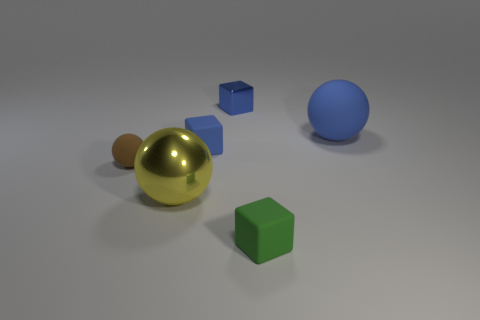Are any yellow metallic spheres visible?
Your response must be concise. Yes. There is a brown thing that is made of the same material as the green cube; what is its shape?
Provide a short and direct response. Sphere. There is a big ball on the right side of the green rubber block; what is it made of?
Your answer should be compact. Rubber. There is a small matte cube behind the small brown matte object; is it the same color as the big matte thing?
Your answer should be compact. Yes. There is a metal thing in front of the blue matte object to the right of the tiny blue metal block; what size is it?
Give a very brief answer. Large. Are there more green rubber things to the right of the small brown thing than yellow cylinders?
Make the answer very short. Yes. Is the size of the blue block to the left of the blue shiny block the same as the green object?
Make the answer very short. Yes. There is a tiny matte object that is both behind the yellow ball and right of the brown matte ball; what color is it?
Ensure brevity in your answer.  Blue. What is the shape of the yellow metallic object that is the same size as the blue ball?
Keep it short and to the point. Sphere. Are there any blocks of the same color as the metal sphere?
Provide a short and direct response. No. 